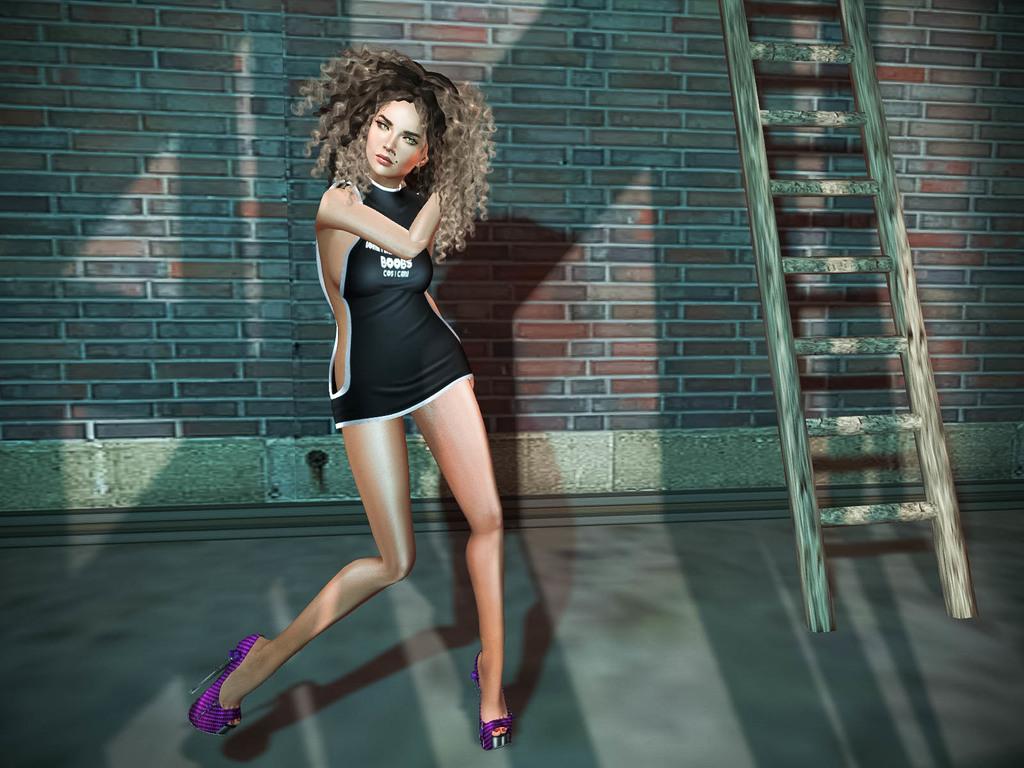What body part is listed on her dress?
Ensure brevity in your answer.  Boobs. 